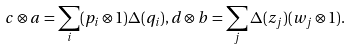Convert formula to latex. <formula><loc_0><loc_0><loc_500><loc_500>c \otimes a = \sum _ { i } ( p _ { i } \otimes 1 ) \Delta ( q _ { i } ) , d \otimes b = \sum _ { j } \Delta ( z _ { j } ) ( w _ { j } \otimes 1 ) .</formula> 